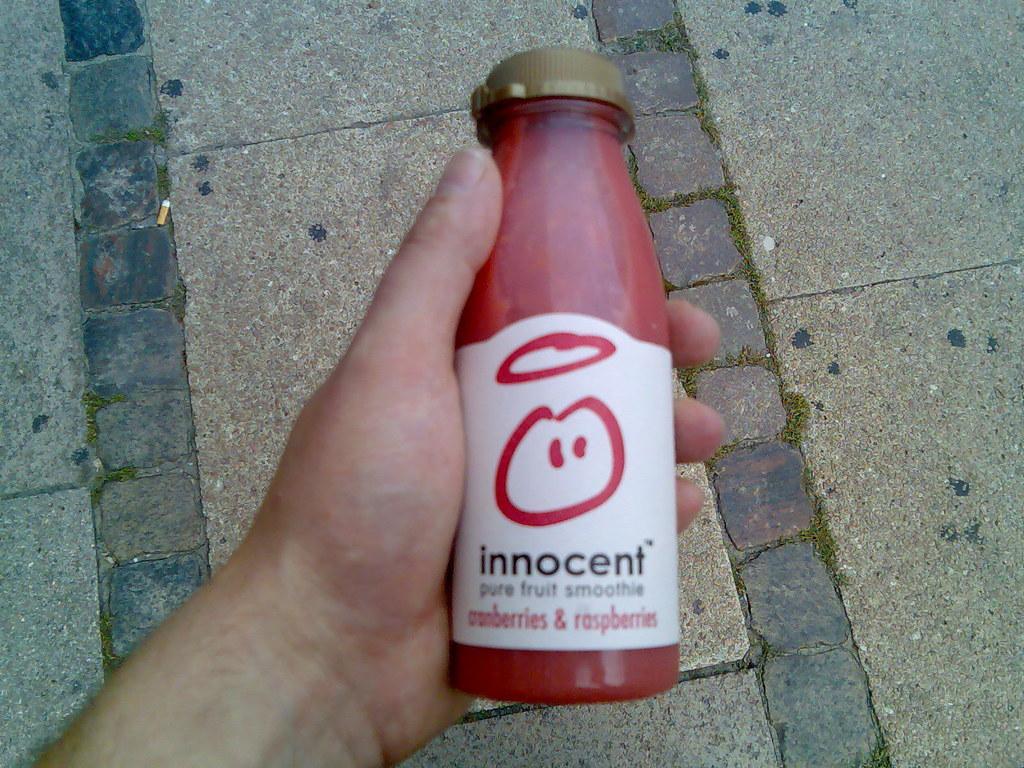Can you describe this image briefly? In this picture we can see a bottle with cap and some person is holding in his hand and here we can see ground. 